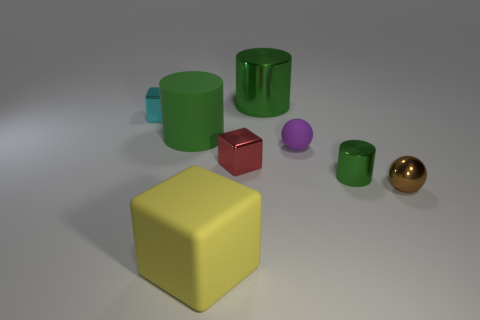How do the objects appear in terms of their brightness or luminosity? The objects have varied levels of brightness. The yellow cube is the brightest, possibly due to its light color and the way it reflects light. The other objects, while also reflective, have colors that absorb more light, making them appear less luminous, with the green and red objects being of medium brightness and the purple and blue objects somewhat darker. 